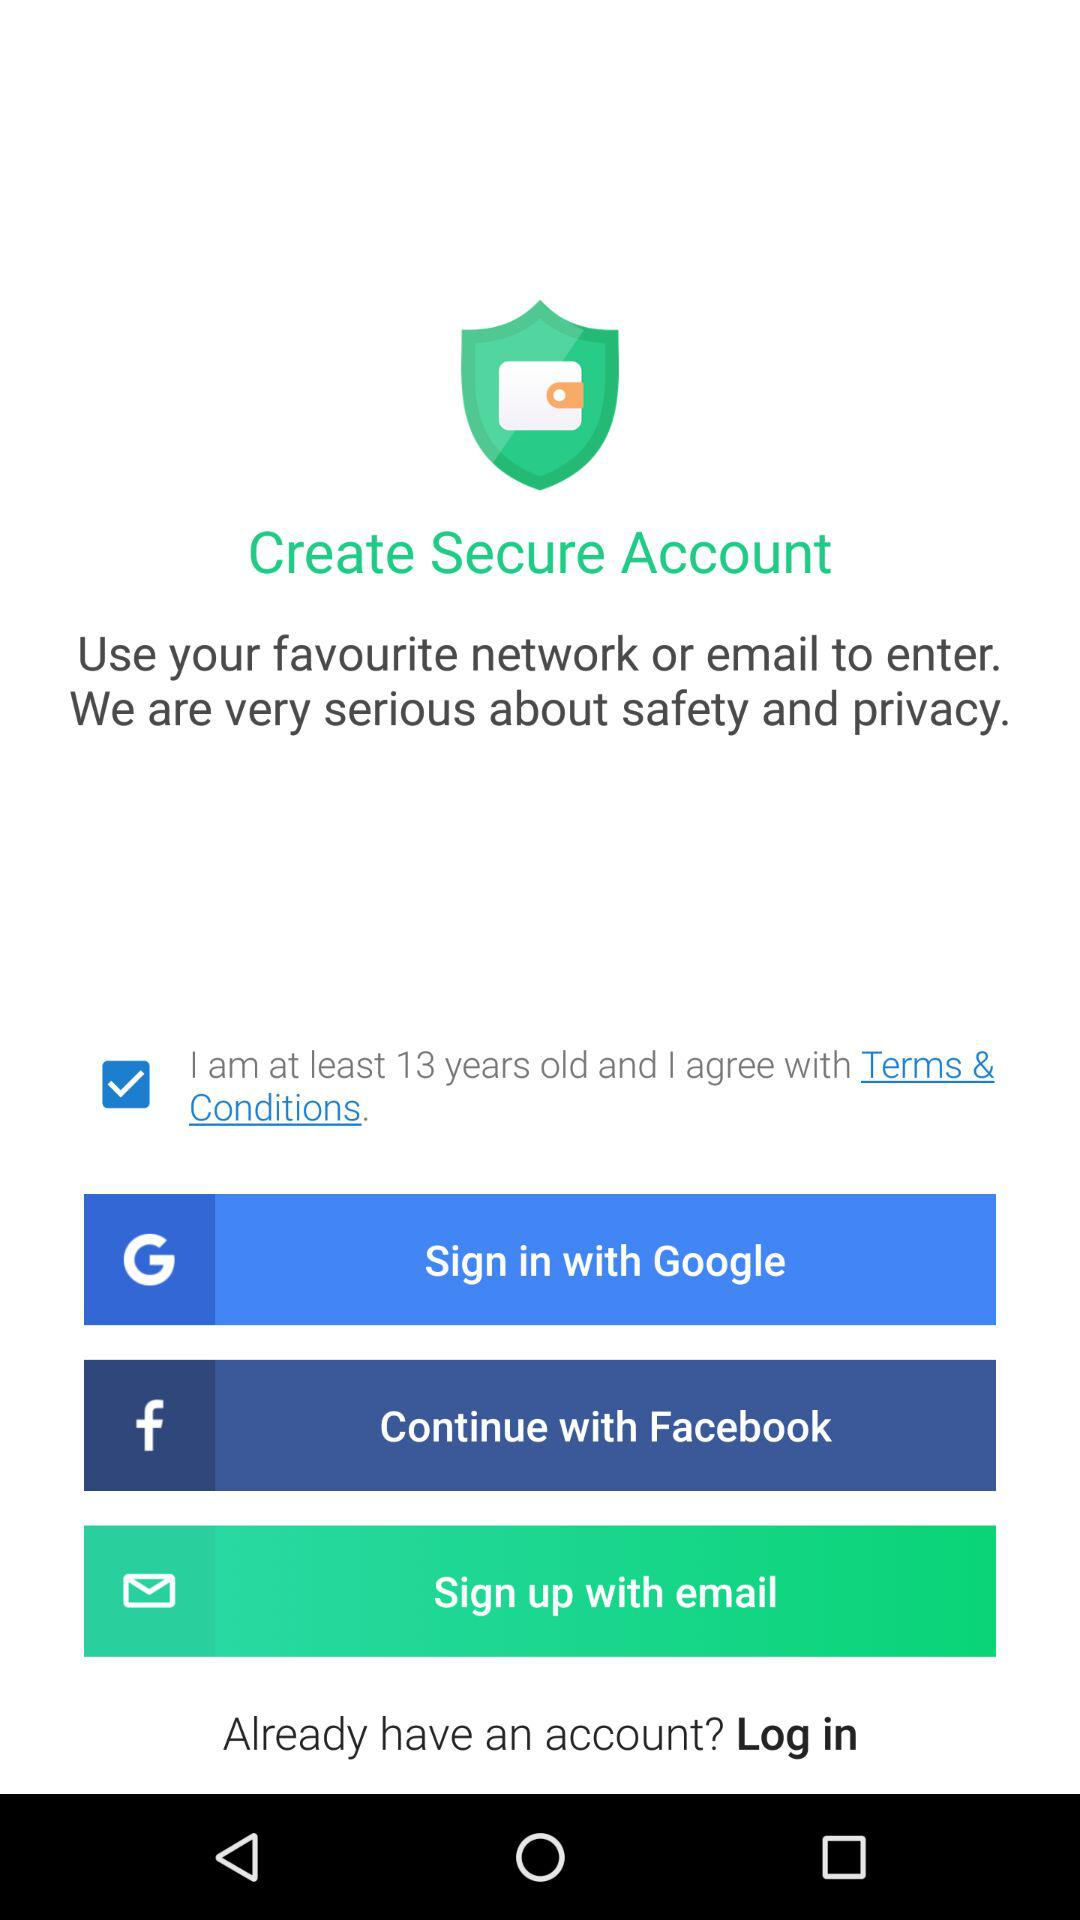How many sign in options are available?
Answer the question using a single word or phrase. 3 